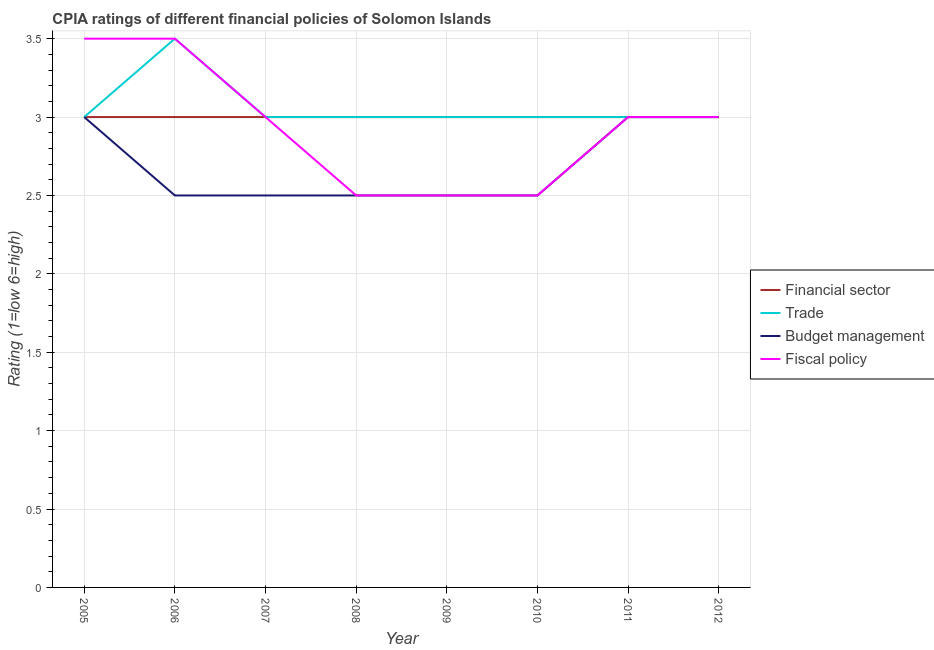Does the line corresponding to cpia rating of fiscal policy intersect with the line corresponding to cpia rating of budget management?
Your answer should be compact. Yes. Is the number of lines equal to the number of legend labels?
Ensure brevity in your answer.  Yes. What is the cpia rating of fiscal policy in 2011?
Provide a succinct answer. 3. Across all years, what is the maximum cpia rating of budget management?
Give a very brief answer. 3. In which year was the cpia rating of fiscal policy minimum?
Your answer should be very brief. 2008. What is the total cpia rating of fiscal policy in the graph?
Make the answer very short. 23.5. What is the difference between the cpia rating of budget management in 2006 and that in 2011?
Your answer should be compact. -0.5. What is the average cpia rating of trade per year?
Your answer should be compact. 3.06. What is the ratio of the cpia rating of budget management in 2007 to that in 2009?
Your answer should be very brief. 1. Is the difference between the cpia rating of fiscal policy in 2008 and 2011 greater than the difference between the cpia rating of financial sector in 2008 and 2011?
Give a very brief answer. No. What is the difference between the highest and the lowest cpia rating of budget management?
Your response must be concise. 0.5. Is it the case that in every year, the sum of the cpia rating of financial sector and cpia rating of trade is greater than the cpia rating of budget management?
Give a very brief answer. Yes. Is the cpia rating of fiscal policy strictly less than the cpia rating of trade over the years?
Provide a succinct answer. No. How many lines are there?
Provide a succinct answer. 4. Does the graph contain grids?
Your answer should be compact. Yes. What is the title of the graph?
Your answer should be compact. CPIA ratings of different financial policies of Solomon Islands. Does "Plant species" appear as one of the legend labels in the graph?
Your answer should be very brief. No. What is the Rating (1=low 6=high) in Fiscal policy in 2005?
Make the answer very short. 3.5. What is the Rating (1=low 6=high) of Trade in 2006?
Your answer should be very brief. 3.5. What is the Rating (1=low 6=high) of Budget management in 2006?
Give a very brief answer. 2.5. What is the Rating (1=low 6=high) in Financial sector in 2007?
Make the answer very short. 3. What is the Rating (1=low 6=high) in Fiscal policy in 2007?
Offer a terse response. 3. What is the Rating (1=low 6=high) in Financial sector in 2008?
Give a very brief answer. 3. What is the Rating (1=low 6=high) of Budget management in 2008?
Your answer should be very brief. 2.5. What is the Rating (1=low 6=high) in Fiscal policy in 2010?
Keep it short and to the point. 2.5. What is the Rating (1=low 6=high) of Budget management in 2011?
Provide a succinct answer. 3. What is the Rating (1=low 6=high) in Fiscal policy in 2011?
Offer a terse response. 3. What is the Rating (1=low 6=high) in Trade in 2012?
Give a very brief answer. 3. What is the Rating (1=low 6=high) in Fiscal policy in 2012?
Offer a very short reply. 3. Across all years, what is the maximum Rating (1=low 6=high) of Trade?
Provide a succinct answer. 3.5. Across all years, what is the maximum Rating (1=low 6=high) of Budget management?
Your response must be concise. 3. Across all years, what is the maximum Rating (1=low 6=high) in Fiscal policy?
Your response must be concise. 3.5. Across all years, what is the minimum Rating (1=low 6=high) in Budget management?
Offer a very short reply. 2.5. Across all years, what is the minimum Rating (1=low 6=high) in Fiscal policy?
Provide a succinct answer. 2.5. What is the total Rating (1=low 6=high) in Financial sector in the graph?
Offer a terse response. 24. What is the total Rating (1=low 6=high) in Trade in the graph?
Your answer should be very brief. 24.5. What is the total Rating (1=low 6=high) in Fiscal policy in the graph?
Provide a short and direct response. 23.5. What is the difference between the Rating (1=low 6=high) in Trade in 2005 and that in 2006?
Your answer should be compact. -0.5. What is the difference between the Rating (1=low 6=high) in Financial sector in 2005 and that in 2007?
Give a very brief answer. 0. What is the difference between the Rating (1=low 6=high) in Trade in 2005 and that in 2007?
Give a very brief answer. 0. What is the difference between the Rating (1=low 6=high) in Budget management in 2005 and that in 2007?
Provide a short and direct response. 0.5. What is the difference between the Rating (1=low 6=high) in Financial sector in 2005 and that in 2008?
Give a very brief answer. 0. What is the difference between the Rating (1=low 6=high) of Trade in 2005 and that in 2008?
Give a very brief answer. 0. What is the difference between the Rating (1=low 6=high) in Budget management in 2005 and that in 2008?
Ensure brevity in your answer.  0.5. What is the difference between the Rating (1=low 6=high) in Fiscal policy in 2005 and that in 2008?
Ensure brevity in your answer.  1. What is the difference between the Rating (1=low 6=high) in Trade in 2005 and that in 2009?
Your answer should be very brief. 0. What is the difference between the Rating (1=low 6=high) of Financial sector in 2005 and that in 2010?
Provide a succinct answer. 0. What is the difference between the Rating (1=low 6=high) of Fiscal policy in 2005 and that in 2010?
Keep it short and to the point. 1. What is the difference between the Rating (1=low 6=high) of Budget management in 2005 and that in 2011?
Provide a short and direct response. 0. What is the difference between the Rating (1=low 6=high) in Fiscal policy in 2005 and that in 2011?
Offer a very short reply. 0.5. What is the difference between the Rating (1=low 6=high) of Financial sector in 2005 and that in 2012?
Give a very brief answer. 0. What is the difference between the Rating (1=low 6=high) of Trade in 2005 and that in 2012?
Your answer should be very brief. 0. What is the difference between the Rating (1=low 6=high) of Budget management in 2006 and that in 2007?
Provide a succinct answer. 0. What is the difference between the Rating (1=low 6=high) in Fiscal policy in 2006 and that in 2008?
Offer a terse response. 1. What is the difference between the Rating (1=low 6=high) in Financial sector in 2006 and that in 2009?
Provide a succinct answer. 0. What is the difference between the Rating (1=low 6=high) of Fiscal policy in 2006 and that in 2009?
Make the answer very short. 1. What is the difference between the Rating (1=low 6=high) in Financial sector in 2006 and that in 2010?
Provide a short and direct response. 0. What is the difference between the Rating (1=low 6=high) in Trade in 2006 and that in 2010?
Your answer should be compact. 0.5. What is the difference between the Rating (1=low 6=high) in Budget management in 2006 and that in 2010?
Offer a very short reply. 0. What is the difference between the Rating (1=low 6=high) of Fiscal policy in 2006 and that in 2010?
Give a very brief answer. 1. What is the difference between the Rating (1=low 6=high) in Trade in 2006 and that in 2011?
Provide a succinct answer. 0.5. What is the difference between the Rating (1=low 6=high) in Budget management in 2006 and that in 2011?
Offer a very short reply. -0.5. What is the difference between the Rating (1=low 6=high) in Fiscal policy in 2006 and that in 2011?
Your answer should be compact. 0.5. What is the difference between the Rating (1=low 6=high) of Budget management in 2006 and that in 2012?
Keep it short and to the point. -0.5. What is the difference between the Rating (1=low 6=high) in Financial sector in 2007 and that in 2008?
Ensure brevity in your answer.  0. What is the difference between the Rating (1=low 6=high) in Trade in 2007 and that in 2008?
Make the answer very short. 0. What is the difference between the Rating (1=low 6=high) in Fiscal policy in 2007 and that in 2008?
Your answer should be very brief. 0.5. What is the difference between the Rating (1=low 6=high) in Trade in 2007 and that in 2009?
Ensure brevity in your answer.  0. What is the difference between the Rating (1=low 6=high) in Budget management in 2007 and that in 2009?
Give a very brief answer. 0. What is the difference between the Rating (1=low 6=high) of Budget management in 2007 and that in 2010?
Your response must be concise. 0. What is the difference between the Rating (1=low 6=high) in Financial sector in 2007 and that in 2011?
Give a very brief answer. 0. What is the difference between the Rating (1=low 6=high) in Trade in 2007 and that in 2011?
Your response must be concise. 0. What is the difference between the Rating (1=low 6=high) of Financial sector in 2007 and that in 2012?
Offer a terse response. 0. What is the difference between the Rating (1=low 6=high) in Budget management in 2007 and that in 2012?
Make the answer very short. -0.5. What is the difference between the Rating (1=low 6=high) of Fiscal policy in 2007 and that in 2012?
Your response must be concise. 0. What is the difference between the Rating (1=low 6=high) of Financial sector in 2008 and that in 2009?
Your response must be concise. 0. What is the difference between the Rating (1=low 6=high) of Trade in 2008 and that in 2009?
Give a very brief answer. 0. What is the difference between the Rating (1=low 6=high) of Financial sector in 2008 and that in 2010?
Your answer should be very brief. 0. What is the difference between the Rating (1=low 6=high) of Trade in 2008 and that in 2010?
Offer a terse response. 0. What is the difference between the Rating (1=low 6=high) of Budget management in 2008 and that in 2010?
Offer a terse response. 0. What is the difference between the Rating (1=low 6=high) in Fiscal policy in 2008 and that in 2010?
Your response must be concise. 0. What is the difference between the Rating (1=low 6=high) in Financial sector in 2008 and that in 2011?
Your answer should be compact. 0. What is the difference between the Rating (1=low 6=high) in Trade in 2008 and that in 2012?
Your answer should be very brief. 0. What is the difference between the Rating (1=low 6=high) in Budget management in 2008 and that in 2012?
Provide a succinct answer. -0.5. What is the difference between the Rating (1=low 6=high) in Financial sector in 2009 and that in 2010?
Provide a succinct answer. 0. What is the difference between the Rating (1=low 6=high) of Fiscal policy in 2009 and that in 2010?
Your response must be concise. 0. What is the difference between the Rating (1=low 6=high) of Financial sector in 2009 and that in 2012?
Provide a short and direct response. 0. What is the difference between the Rating (1=low 6=high) of Budget management in 2009 and that in 2012?
Your answer should be compact. -0.5. What is the difference between the Rating (1=low 6=high) in Financial sector in 2010 and that in 2011?
Your response must be concise. 0. What is the difference between the Rating (1=low 6=high) in Budget management in 2010 and that in 2011?
Give a very brief answer. -0.5. What is the difference between the Rating (1=low 6=high) of Fiscal policy in 2010 and that in 2011?
Provide a short and direct response. -0.5. What is the difference between the Rating (1=low 6=high) of Financial sector in 2010 and that in 2012?
Make the answer very short. 0. What is the difference between the Rating (1=low 6=high) of Trade in 2010 and that in 2012?
Give a very brief answer. 0. What is the difference between the Rating (1=low 6=high) of Budget management in 2010 and that in 2012?
Provide a short and direct response. -0.5. What is the difference between the Rating (1=low 6=high) of Financial sector in 2011 and that in 2012?
Your response must be concise. 0. What is the difference between the Rating (1=low 6=high) in Budget management in 2011 and that in 2012?
Offer a very short reply. 0. What is the difference between the Rating (1=low 6=high) of Financial sector in 2005 and the Rating (1=low 6=high) of Trade in 2006?
Provide a succinct answer. -0.5. What is the difference between the Rating (1=low 6=high) in Financial sector in 2005 and the Rating (1=low 6=high) in Budget management in 2006?
Give a very brief answer. 0.5. What is the difference between the Rating (1=low 6=high) in Trade in 2005 and the Rating (1=low 6=high) in Budget management in 2006?
Keep it short and to the point. 0.5. What is the difference between the Rating (1=low 6=high) in Financial sector in 2005 and the Rating (1=low 6=high) in Trade in 2007?
Keep it short and to the point. 0. What is the difference between the Rating (1=low 6=high) in Financial sector in 2005 and the Rating (1=low 6=high) in Fiscal policy in 2007?
Give a very brief answer. 0. What is the difference between the Rating (1=low 6=high) in Trade in 2005 and the Rating (1=low 6=high) in Fiscal policy in 2007?
Provide a short and direct response. 0. What is the difference between the Rating (1=low 6=high) of Trade in 2005 and the Rating (1=low 6=high) of Budget management in 2008?
Offer a terse response. 0.5. What is the difference between the Rating (1=low 6=high) of Trade in 2005 and the Rating (1=low 6=high) of Fiscal policy in 2008?
Ensure brevity in your answer.  0.5. What is the difference between the Rating (1=low 6=high) in Budget management in 2005 and the Rating (1=low 6=high) in Fiscal policy in 2008?
Offer a terse response. 0.5. What is the difference between the Rating (1=low 6=high) in Financial sector in 2005 and the Rating (1=low 6=high) in Trade in 2009?
Provide a short and direct response. 0. What is the difference between the Rating (1=low 6=high) in Financial sector in 2005 and the Rating (1=low 6=high) in Fiscal policy in 2009?
Make the answer very short. 0.5. What is the difference between the Rating (1=low 6=high) of Trade in 2005 and the Rating (1=low 6=high) of Budget management in 2009?
Your response must be concise. 0.5. What is the difference between the Rating (1=low 6=high) of Financial sector in 2005 and the Rating (1=low 6=high) of Budget management in 2010?
Give a very brief answer. 0.5. What is the difference between the Rating (1=low 6=high) in Trade in 2005 and the Rating (1=low 6=high) in Fiscal policy in 2010?
Make the answer very short. 0.5. What is the difference between the Rating (1=low 6=high) of Budget management in 2005 and the Rating (1=low 6=high) of Fiscal policy in 2010?
Offer a very short reply. 0.5. What is the difference between the Rating (1=low 6=high) in Financial sector in 2005 and the Rating (1=low 6=high) in Trade in 2011?
Make the answer very short. 0. What is the difference between the Rating (1=low 6=high) in Financial sector in 2005 and the Rating (1=low 6=high) in Fiscal policy in 2011?
Make the answer very short. 0. What is the difference between the Rating (1=low 6=high) of Budget management in 2005 and the Rating (1=low 6=high) of Fiscal policy in 2011?
Your response must be concise. 0. What is the difference between the Rating (1=low 6=high) of Financial sector in 2005 and the Rating (1=low 6=high) of Trade in 2012?
Offer a terse response. 0. What is the difference between the Rating (1=low 6=high) of Financial sector in 2005 and the Rating (1=low 6=high) of Fiscal policy in 2012?
Ensure brevity in your answer.  0. What is the difference between the Rating (1=low 6=high) of Trade in 2005 and the Rating (1=low 6=high) of Budget management in 2012?
Your answer should be compact. 0. What is the difference between the Rating (1=low 6=high) of Financial sector in 2006 and the Rating (1=low 6=high) of Trade in 2007?
Make the answer very short. 0. What is the difference between the Rating (1=low 6=high) in Trade in 2006 and the Rating (1=low 6=high) in Fiscal policy in 2007?
Your response must be concise. 0.5. What is the difference between the Rating (1=low 6=high) in Trade in 2006 and the Rating (1=low 6=high) in Budget management in 2008?
Offer a terse response. 1. What is the difference between the Rating (1=low 6=high) of Trade in 2006 and the Rating (1=low 6=high) of Budget management in 2009?
Keep it short and to the point. 1. What is the difference between the Rating (1=low 6=high) of Trade in 2006 and the Rating (1=low 6=high) of Fiscal policy in 2009?
Provide a succinct answer. 1. What is the difference between the Rating (1=low 6=high) in Budget management in 2006 and the Rating (1=low 6=high) in Fiscal policy in 2009?
Your answer should be compact. 0. What is the difference between the Rating (1=low 6=high) of Financial sector in 2006 and the Rating (1=low 6=high) of Budget management in 2010?
Your answer should be compact. 0.5. What is the difference between the Rating (1=low 6=high) of Financial sector in 2006 and the Rating (1=low 6=high) of Fiscal policy in 2010?
Provide a short and direct response. 0.5. What is the difference between the Rating (1=low 6=high) in Trade in 2006 and the Rating (1=low 6=high) in Budget management in 2010?
Keep it short and to the point. 1. What is the difference between the Rating (1=low 6=high) in Financial sector in 2006 and the Rating (1=low 6=high) in Trade in 2011?
Offer a very short reply. 0. What is the difference between the Rating (1=low 6=high) of Financial sector in 2006 and the Rating (1=low 6=high) of Fiscal policy in 2011?
Your answer should be compact. 0. What is the difference between the Rating (1=low 6=high) in Trade in 2006 and the Rating (1=low 6=high) in Budget management in 2011?
Make the answer very short. 0.5. What is the difference between the Rating (1=low 6=high) in Financial sector in 2006 and the Rating (1=low 6=high) in Trade in 2012?
Provide a short and direct response. 0. What is the difference between the Rating (1=low 6=high) of Financial sector in 2006 and the Rating (1=low 6=high) of Budget management in 2012?
Make the answer very short. 0. What is the difference between the Rating (1=low 6=high) in Trade in 2006 and the Rating (1=low 6=high) in Budget management in 2012?
Provide a succinct answer. 0.5. What is the difference between the Rating (1=low 6=high) of Budget management in 2006 and the Rating (1=low 6=high) of Fiscal policy in 2012?
Your answer should be very brief. -0.5. What is the difference between the Rating (1=low 6=high) in Financial sector in 2007 and the Rating (1=low 6=high) in Budget management in 2008?
Keep it short and to the point. 0.5. What is the difference between the Rating (1=low 6=high) in Financial sector in 2007 and the Rating (1=low 6=high) in Fiscal policy in 2008?
Make the answer very short. 0.5. What is the difference between the Rating (1=low 6=high) in Trade in 2007 and the Rating (1=low 6=high) in Budget management in 2008?
Offer a terse response. 0.5. What is the difference between the Rating (1=low 6=high) in Budget management in 2007 and the Rating (1=low 6=high) in Fiscal policy in 2008?
Provide a short and direct response. 0. What is the difference between the Rating (1=low 6=high) of Trade in 2007 and the Rating (1=low 6=high) of Fiscal policy in 2009?
Your response must be concise. 0.5. What is the difference between the Rating (1=low 6=high) of Budget management in 2007 and the Rating (1=low 6=high) of Fiscal policy in 2009?
Offer a very short reply. 0. What is the difference between the Rating (1=low 6=high) in Financial sector in 2007 and the Rating (1=low 6=high) in Trade in 2010?
Make the answer very short. 0. What is the difference between the Rating (1=low 6=high) in Financial sector in 2007 and the Rating (1=low 6=high) in Fiscal policy in 2010?
Provide a succinct answer. 0.5. What is the difference between the Rating (1=low 6=high) of Trade in 2007 and the Rating (1=low 6=high) of Fiscal policy in 2010?
Offer a very short reply. 0.5. What is the difference between the Rating (1=low 6=high) of Budget management in 2007 and the Rating (1=low 6=high) of Fiscal policy in 2010?
Give a very brief answer. 0. What is the difference between the Rating (1=low 6=high) in Financial sector in 2007 and the Rating (1=low 6=high) in Fiscal policy in 2011?
Provide a succinct answer. 0. What is the difference between the Rating (1=low 6=high) in Trade in 2007 and the Rating (1=low 6=high) in Budget management in 2011?
Offer a terse response. 0. What is the difference between the Rating (1=low 6=high) of Trade in 2007 and the Rating (1=low 6=high) of Fiscal policy in 2011?
Make the answer very short. 0. What is the difference between the Rating (1=low 6=high) of Financial sector in 2007 and the Rating (1=low 6=high) of Budget management in 2012?
Keep it short and to the point. 0. What is the difference between the Rating (1=low 6=high) in Financial sector in 2007 and the Rating (1=low 6=high) in Fiscal policy in 2012?
Keep it short and to the point. 0. What is the difference between the Rating (1=low 6=high) in Trade in 2007 and the Rating (1=low 6=high) in Budget management in 2012?
Provide a succinct answer. 0. What is the difference between the Rating (1=low 6=high) of Trade in 2007 and the Rating (1=low 6=high) of Fiscal policy in 2012?
Make the answer very short. 0. What is the difference between the Rating (1=low 6=high) in Budget management in 2007 and the Rating (1=low 6=high) in Fiscal policy in 2012?
Provide a short and direct response. -0.5. What is the difference between the Rating (1=low 6=high) of Financial sector in 2008 and the Rating (1=low 6=high) of Trade in 2009?
Your response must be concise. 0. What is the difference between the Rating (1=low 6=high) in Financial sector in 2008 and the Rating (1=low 6=high) in Budget management in 2009?
Ensure brevity in your answer.  0.5. What is the difference between the Rating (1=low 6=high) in Financial sector in 2008 and the Rating (1=low 6=high) in Fiscal policy in 2009?
Provide a succinct answer. 0.5. What is the difference between the Rating (1=low 6=high) of Trade in 2008 and the Rating (1=low 6=high) of Budget management in 2009?
Offer a terse response. 0.5. What is the difference between the Rating (1=low 6=high) of Trade in 2008 and the Rating (1=low 6=high) of Fiscal policy in 2009?
Make the answer very short. 0.5. What is the difference between the Rating (1=low 6=high) in Budget management in 2008 and the Rating (1=low 6=high) in Fiscal policy in 2009?
Provide a succinct answer. 0. What is the difference between the Rating (1=low 6=high) of Financial sector in 2008 and the Rating (1=low 6=high) of Trade in 2010?
Make the answer very short. 0. What is the difference between the Rating (1=low 6=high) of Financial sector in 2008 and the Rating (1=low 6=high) of Budget management in 2010?
Provide a succinct answer. 0.5. What is the difference between the Rating (1=low 6=high) of Financial sector in 2008 and the Rating (1=low 6=high) of Fiscal policy in 2010?
Your answer should be compact. 0.5. What is the difference between the Rating (1=low 6=high) of Trade in 2008 and the Rating (1=low 6=high) of Fiscal policy in 2010?
Your response must be concise. 0.5. What is the difference between the Rating (1=low 6=high) in Budget management in 2008 and the Rating (1=low 6=high) in Fiscal policy in 2010?
Offer a terse response. 0. What is the difference between the Rating (1=low 6=high) in Financial sector in 2008 and the Rating (1=low 6=high) in Trade in 2011?
Give a very brief answer. 0. What is the difference between the Rating (1=low 6=high) of Financial sector in 2008 and the Rating (1=low 6=high) of Budget management in 2011?
Provide a short and direct response. 0. What is the difference between the Rating (1=low 6=high) in Financial sector in 2008 and the Rating (1=low 6=high) in Fiscal policy in 2011?
Your answer should be compact. 0. What is the difference between the Rating (1=low 6=high) of Trade in 2008 and the Rating (1=low 6=high) of Budget management in 2011?
Keep it short and to the point. 0. What is the difference between the Rating (1=low 6=high) in Budget management in 2008 and the Rating (1=low 6=high) in Fiscal policy in 2011?
Your response must be concise. -0.5. What is the difference between the Rating (1=low 6=high) of Financial sector in 2008 and the Rating (1=low 6=high) of Trade in 2012?
Your response must be concise. 0. What is the difference between the Rating (1=low 6=high) in Financial sector in 2008 and the Rating (1=low 6=high) in Budget management in 2012?
Your answer should be compact. 0. What is the difference between the Rating (1=low 6=high) in Financial sector in 2008 and the Rating (1=low 6=high) in Fiscal policy in 2012?
Provide a short and direct response. 0. What is the difference between the Rating (1=low 6=high) in Trade in 2008 and the Rating (1=low 6=high) in Budget management in 2012?
Give a very brief answer. 0. What is the difference between the Rating (1=low 6=high) in Financial sector in 2009 and the Rating (1=low 6=high) in Trade in 2010?
Ensure brevity in your answer.  0. What is the difference between the Rating (1=low 6=high) of Financial sector in 2009 and the Rating (1=low 6=high) of Budget management in 2010?
Offer a terse response. 0.5. What is the difference between the Rating (1=low 6=high) of Trade in 2009 and the Rating (1=low 6=high) of Fiscal policy in 2010?
Provide a succinct answer. 0.5. What is the difference between the Rating (1=low 6=high) of Budget management in 2009 and the Rating (1=low 6=high) of Fiscal policy in 2010?
Give a very brief answer. 0. What is the difference between the Rating (1=low 6=high) of Financial sector in 2009 and the Rating (1=low 6=high) of Trade in 2011?
Make the answer very short. 0. What is the difference between the Rating (1=low 6=high) of Financial sector in 2009 and the Rating (1=low 6=high) of Fiscal policy in 2011?
Your response must be concise. 0. What is the difference between the Rating (1=low 6=high) in Trade in 2009 and the Rating (1=low 6=high) in Budget management in 2011?
Provide a short and direct response. 0. What is the difference between the Rating (1=low 6=high) in Trade in 2009 and the Rating (1=low 6=high) in Fiscal policy in 2011?
Ensure brevity in your answer.  0. What is the difference between the Rating (1=low 6=high) of Budget management in 2009 and the Rating (1=low 6=high) of Fiscal policy in 2011?
Offer a very short reply. -0.5. What is the difference between the Rating (1=low 6=high) in Financial sector in 2009 and the Rating (1=low 6=high) in Trade in 2012?
Your answer should be very brief. 0. What is the difference between the Rating (1=low 6=high) of Trade in 2009 and the Rating (1=low 6=high) of Budget management in 2012?
Offer a terse response. 0. What is the difference between the Rating (1=low 6=high) in Trade in 2009 and the Rating (1=low 6=high) in Fiscal policy in 2012?
Your response must be concise. 0. What is the difference between the Rating (1=low 6=high) in Budget management in 2009 and the Rating (1=low 6=high) in Fiscal policy in 2012?
Provide a succinct answer. -0.5. What is the difference between the Rating (1=low 6=high) in Financial sector in 2010 and the Rating (1=low 6=high) in Trade in 2011?
Your response must be concise. 0. What is the difference between the Rating (1=low 6=high) in Financial sector in 2010 and the Rating (1=low 6=high) in Budget management in 2012?
Provide a succinct answer. 0. What is the difference between the Rating (1=low 6=high) of Financial sector in 2010 and the Rating (1=low 6=high) of Fiscal policy in 2012?
Give a very brief answer. 0. What is the difference between the Rating (1=low 6=high) of Trade in 2010 and the Rating (1=low 6=high) of Budget management in 2012?
Keep it short and to the point. 0. What is the difference between the Rating (1=low 6=high) of Trade in 2010 and the Rating (1=low 6=high) of Fiscal policy in 2012?
Make the answer very short. 0. What is the difference between the Rating (1=low 6=high) in Budget management in 2010 and the Rating (1=low 6=high) in Fiscal policy in 2012?
Ensure brevity in your answer.  -0.5. What is the difference between the Rating (1=low 6=high) of Trade in 2011 and the Rating (1=low 6=high) of Fiscal policy in 2012?
Provide a short and direct response. 0. What is the average Rating (1=low 6=high) of Trade per year?
Your response must be concise. 3.06. What is the average Rating (1=low 6=high) of Budget management per year?
Give a very brief answer. 2.69. What is the average Rating (1=low 6=high) of Fiscal policy per year?
Your answer should be very brief. 2.94. In the year 2005, what is the difference between the Rating (1=low 6=high) of Financial sector and Rating (1=low 6=high) of Trade?
Your answer should be compact. 0. In the year 2005, what is the difference between the Rating (1=low 6=high) in Trade and Rating (1=low 6=high) in Fiscal policy?
Provide a short and direct response. -0.5. In the year 2005, what is the difference between the Rating (1=low 6=high) of Budget management and Rating (1=low 6=high) of Fiscal policy?
Provide a succinct answer. -0.5. In the year 2006, what is the difference between the Rating (1=low 6=high) of Financial sector and Rating (1=low 6=high) of Trade?
Ensure brevity in your answer.  -0.5. In the year 2006, what is the difference between the Rating (1=low 6=high) in Financial sector and Rating (1=low 6=high) in Budget management?
Keep it short and to the point. 0.5. In the year 2006, what is the difference between the Rating (1=low 6=high) in Trade and Rating (1=low 6=high) in Budget management?
Your response must be concise. 1. In the year 2007, what is the difference between the Rating (1=low 6=high) in Financial sector and Rating (1=low 6=high) in Trade?
Give a very brief answer. 0. In the year 2007, what is the difference between the Rating (1=low 6=high) of Financial sector and Rating (1=low 6=high) of Budget management?
Ensure brevity in your answer.  0.5. In the year 2007, what is the difference between the Rating (1=low 6=high) in Financial sector and Rating (1=low 6=high) in Fiscal policy?
Offer a very short reply. 0. In the year 2007, what is the difference between the Rating (1=low 6=high) in Trade and Rating (1=low 6=high) in Budget management?
Give a very brief answer. 0.5. In the year 2007, what is the difference between the Rating (1=low 6=high) of Trade and Rating (1=low 6=high) of Fiscal policy?
Your answer should be very brief. 0. In the year 2007, what is the difference between the Rating (1=low 6=high) in Budget management and Rating (1=low 6=high) in Fiscal policy?
Make the answer very short. -0.5. In the year 2008, what is the difference between the Rating (1=low 6=high) of Trade and Rating (1=low 6=high) of Budget management?
Provide a succinct answer. 0.5. In the year 2008, what is the difference between the Rating (1=low 6=high) in Budget management and Rating (1=low 6=high) in Fiscal policy?
Give a very brief answer. 0. In the year 2009, what is the difference between the Rating (1=low 6=high) in Financial sector and Rating (1=low 6=high) in Budget management?
Your answer should be compact. 0.5. In the year 2009, what is the difference between the Rating (1=low 6=high) in Financial sector and Rating (1=low 6=high) in Fiscal policy?
Provide a short and direct response. 0.5. In the year 2009, what is the difference between the Rating (1=low 6=high) in Trade and Rating (1=low 6=high) in Budget management?
Your response must be concise. 0.5. In the year 2009, what is the difference between the Rating (1=low 6=high) of Budget management and Rating (1=low 6=high) of Fiscal policy?
Your response must be concise. 0. In the year 2010, what is the difference between the Rating (1=low 6=high) in Trade and Rating (1=low 6=high) in Fiscal policy?
Offer a terse response. 0.5. In the year 2011, what is the difference between the Rating (1=low 6=high) of Financial sector and Rating (1=low 6=high) of Trade?
Provide a short and direct response. 0. In the year 2011, what is the difference between the Rating (1=low 6=high) in Financial sector and Rating (1=low 6=high) in Budget management?
Your response must be concise. 0. In the year 2011, what is the difference between the Rating (1=low 6=high) of Trade and Rating (1=low 6=high) of Budget management?
Your response must be concise. 0. In the year 2011, what is the difference between the Rating (1=low 6=high) in Trade and Rating (1=low 6=high) in Fiscal policy?
Give a very brief answer. 0. In the year 2011, what is the difference between the Rating (1=low 6=high) of Budget management and Rating (1=low 6=high) of Fiscal policy?
Ensure brevity in your answer.  0. In the year 2012, what is the difference between the Rating (1=low 6=high) of Financial sector and Rating (1=low 6=high) of Budget management?
Ensure brevity in your answer.  0. In the year 2012, what is the difference between the Rating (1=low 6=high) in Financial sector and Rating (1=low 6=high) in Fiscal policy?
Your response must be concise. 0. In the year 2012, what is the difference between the Rating (1=low 6=high) of Trade and Rating (1=low 6=high) of Budget management?
Your answer should be compact. 0. In the year 2012, what is the difference between the Rating (1=low 6=high) of Trade and Rating (1=low 6=high) of Fiscal policy?
Your answer should be very brief. 0. What is the ratio of the Rating (1=low 6=high) of Budget management in 2005 to that in 2006?
Your answer should be very brief. 1.2. What is the ratio of the Rating (1=low 6=high) of Fiscal policy in 2005 to that in 2006?
Offer a very short reply. 1. What is the ratio of the Rating (1=low 6=high) in Trade in 2005 to that in 2007?
Offer a terse response. 1. What is the ratio of the Rating (1=low 6=high) of Fiscal policy in 2005 to that in 2007?
Provide a succinct answer. 1.17. What is the ratio of the Rating (1=low 6=high) of Trade in 2005 to that in 2008?
Ensure brevity in your answer.  1. What is the ratio of the Rating (1=low 6=high) of Fiscal policy in 2005 to that in 2008?
Offer a terse response. 1.4. What is the ratio of the Rating (1=low 6=high) of Financial sector in 2005 to that in 2009?
Provide a short and direct response. 1. What is the ratio of the Rating (1=low 6=high) of Fiscal policy in 2005 to that in 2009?
Ensure brevity in your answer.  1.4. What is the ratio of the Rating (1=low 6=high) of Financial sector in 2005 to that in 2010?
Offer a very short reply. 1. What is the ratio of the Rating (1=low 6=high) of Trade in 2005 to that in 2010?
Ensure brevity in your answer.  1. What is the ratio of the Rating (1=low 6=high) of Budget management in 2005 to that in 2010?
Provide a succinct answer. 1.2. What is the ratio of the Rating (1=low 6=high) in Financial sector in 2005 to that in 2012?
Offer a very short reply. 1. What is the ratio of the Rating (1=low 6=high) of Trade in 2005 to that in 2012?
Provide a short and direct response. 1. What is the ratio of the Rating (1=low 6=high) in Budget management in 2005 to that in 2012?
Your response must be concise. 1. What is the ratio of the Rating (1=low 6=high) of Fiscal policy in 2006 to that in 2007?
Your answer should be compact. 1.17. What is the ratio of the Rating (1=low 6=high) of Budget management in 2006 to that in 2008?
Ensure brevity in your answer.  1. What is the ratio of the Rating (1=low 6=high) in Budget management in 2006 to that in 2009?
Make the answer very short. 1. What is the ratio of the Rating (1=low 6=high) in Financial sector in 2006 to that in 2010?
Keep it short and to the point. 1. What is the ratio of the Rating (1=low 6=high) of Trade in 2006 to that in 2010?
Offer a very short reply. 1.17. What is the ratio of the Rating (1=low 6=high) in Budget management in 2006 to that in 2010?
Your answer should be compact. 1. What is the ratio of the Rating (1=low 6=high) in Financial sector in 2006 to that in 2011?
Provide a short and direct response. 1. What is the ratio of the Rating (1=low 6=high) in Trade in 2006 to that in 2011?
Provide a succinct answer. 1.17. What is the ratio of the Rating (1=low 6=high) in Fiscal policy in 2006 to that in 2011?
Offer a very short reply. 1.17. What is the ratio of the Rating (1=low 6=high) in Fiscal policy in 2006 to that in 2012?
Keep it short and to the point. 1.17. What is the ratio of the Rating (1=low 6=high) of Trade in 2007 to that in 2008?
Make the answer very short. 1. What is the ratio of the Rating (1=low 6=high) of Fiscal policy in 2007 to that in 2008?
Provide a short and direct response. 1.2. What is the ratio of the Rating (1=low 6=high) of Trade in 2007 to that in 2009?
Provide a short and direct response. 1. What is the ratio of the Rating (1=low 6=high) of Budget management in 2007 to that in 2009?
Offer a very short reply. 1. What is the ratio of the Rating (1=low 6=high) of Financial sector in 2007 to that in 2010?
Your response must be concise. 1. What is the ratio of the Rating (1=low 6=high) of Trade in 2007 to that in 2010?
Ensure brevity in your answer.  1. What is the ratio of the Rating (1=low 6=high) of Fiscal policy in 2007 to that in 2010?
Provide a succinct answer. 1.2. What is the ratio of the Rating (1=low 6=high) in Budget management in 2007 to that in 2011?
Your answer should be very brief. 0.83. What is the ratio of the Rating (1=low 6=high) of Fiscal policy in 2007 to that in 2011?
Ensure brevity in your answer.  1. What is the ratio of the Rating (1=low 6=high) of Financial sector in 2007 to that in 2012?
Make the answer very short. 1. What is the ratio of the Rating (1=low 6=high) of Trade in 2007 to that in 2012?
Make the answer very short. 1. What is the ratio of the Rating (1=low 6=high) of Budget management in 2007 to that in 2012?
Ensure brevity in your answer.  0.83. What is the ratio of the Rating (1=low 6=high) of Financial sector in 2008 to that in 2009?
Give a very brief answer. 1. What is the ratio of the Rating (1=low 6=high) of Trade in 2008 to that in 2009?
Provide a short and direct response. 1. What is the ratio of the Rating (1=low 6=high) in Fiscal policy in 2008 to that in 2009?
Give a very brief answer. 1. What is the ratio of the Rating (1=low 6=high) of Financial sector in 2008 to that in 2010?
Your answer should be compact. 1. What is the ratio of the Rating (1=low 6=high) of Fiscal policy in 2008 to that in 2010?
Provide a short and direct response. 1. What is the ratio of the Rating (1=low 6=high) of Financial sector in 2008 to that in 2011?
Provide a short and direct response. 1. What is the ratio of the Rating (1=low 6=high) in Trade in 2008 to that in 2011?
Your response must be concise. 1. What is the ratio of the Rating (1=low 6=high) of Financial sector in 2008 to that in 2012?
Make the answer very short. 1. What is the ratio of the Rating (1=low 6=high) in Budget management in 2008 to that in 2012?
Your answer should be very brief. 0.83. What is the ratio of the Rating (1=low 6=high) in Fiscal policy in 2008 to that in 2012?
Ensure brevity in your answer.  0.83. What is the ratio of the Rating (1=low 6=high) in Financial sector in 2009 to that in 2010?
Keep it short and to the point. 1. What is the ratio of the Rating (1=low 6=high) in Trade in 2009 to that in 2010?
Your response must be concise. 1. What is the ratio of the Rating (1=low 6=high) of Fiscal policy in 2009 to that in 2010?
Make the answer very short. 1. What is the ratio of the Rating (1=low 6=high) in Fiscal policy in 2009 to that in 2011?
Your answer should be compact. 0.83. What is the ratio of the Rating (1=low 6=high) of Financial sector in 2009 to that in 2012?
Ensure brevity in your answer.  1. What is the ratio of the Rating (1=low 6=high) of Trade in 2009 to that in 2012?
Keep it short and to the point. 1. What is the ratio of the Rating (1=low 6=high) in Fiscal policy in 2009 to that in 2012?
Your answer should be compact. 0.83. What is the ratio of the Rating (1=low 6=high) in Trade in 2010 to that in 2012?
Ensure brevity in your answer.  1. What is the ratio of the Rating (1=low 6=high) of Fiscal policy in 2011 to that in 2012?
Provide a succinct answer. 1. What is the difference between the highest and the second highest Rating (1=low 6=high) in Financial sector?
Offer a very short reply. 0. What is the difference between the highest and the second highest Rating (1=low 6=high) in Fiscal policy?
Provide a succinct answer. 0. What is the difference between the highest and the lowest Rating (1=low 6=high) of Financial sector?
Give a very brief answer. 0. What is the difference between the highest and the lowest Rating (1=low 6=high) in Trade?
Make the answer very short. 0.5. What is the difference between the highest and the lowest Rating (1=low 6=high) of Budget management?
Give a very brief answer. 0.5. What is the difference between the highest and the lowest Rating (1=low 6=high) of Fiscal policy?
Make the answer very short. 1. 